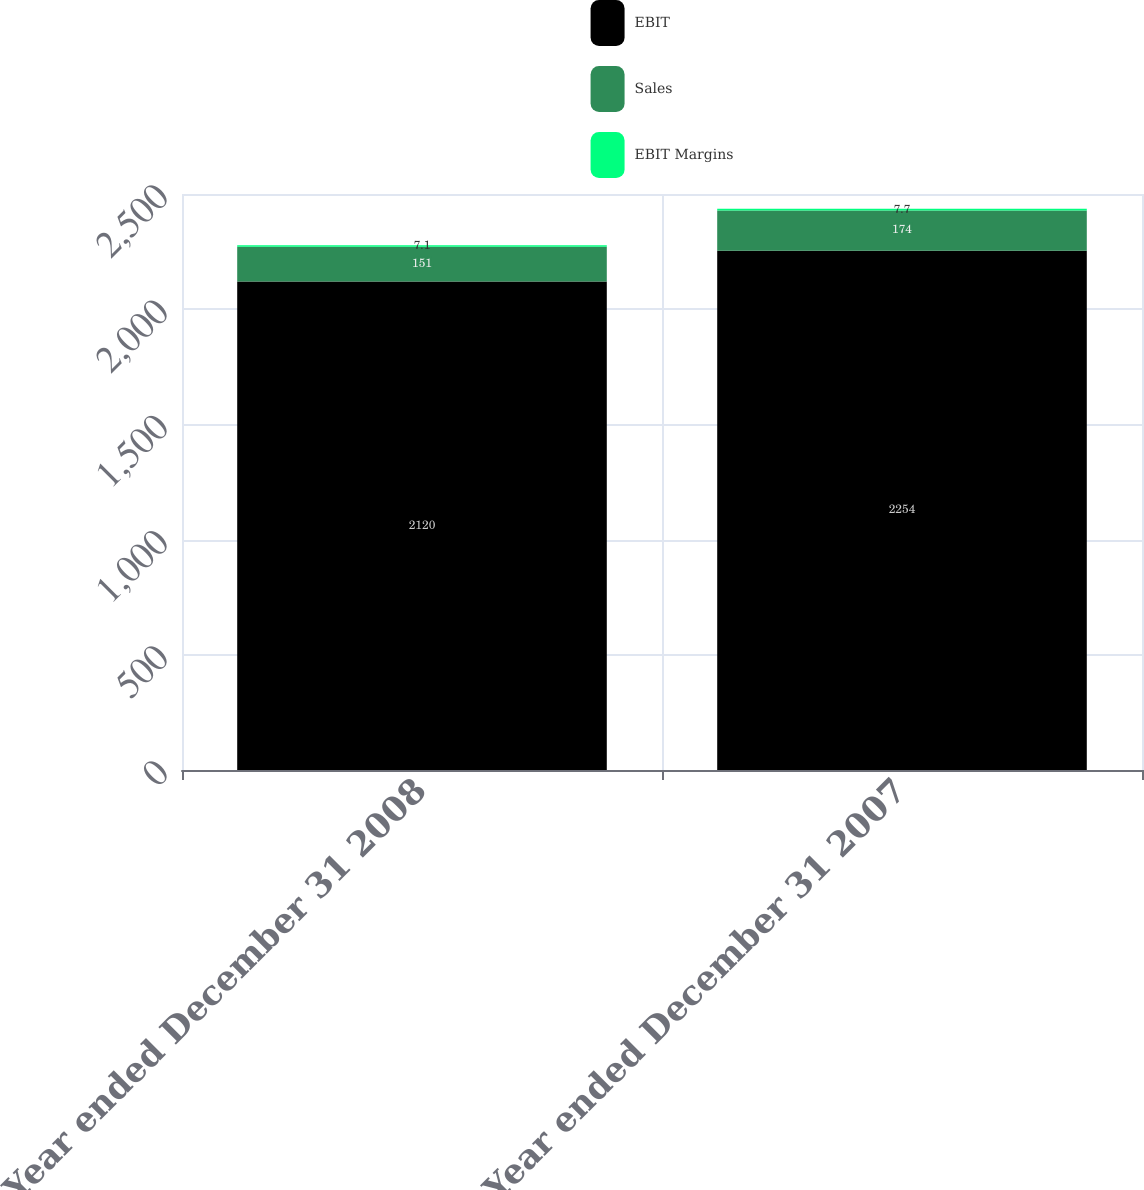Convert chart. <chart><loc_0><loc_0><loc_500><loc_500><stacked_bar_chart><ecel><fcel>Year ended December 31 2008<fcel>Year ended December 31 2007<nl><fcel>EBIT<fcel>2120<fcel>2254<nl><fcel>Sales<fcel>151<fcel>174<nl><fcel>EBIT Margins<fcel>7.1<fcel>7.7<nl></chart> 